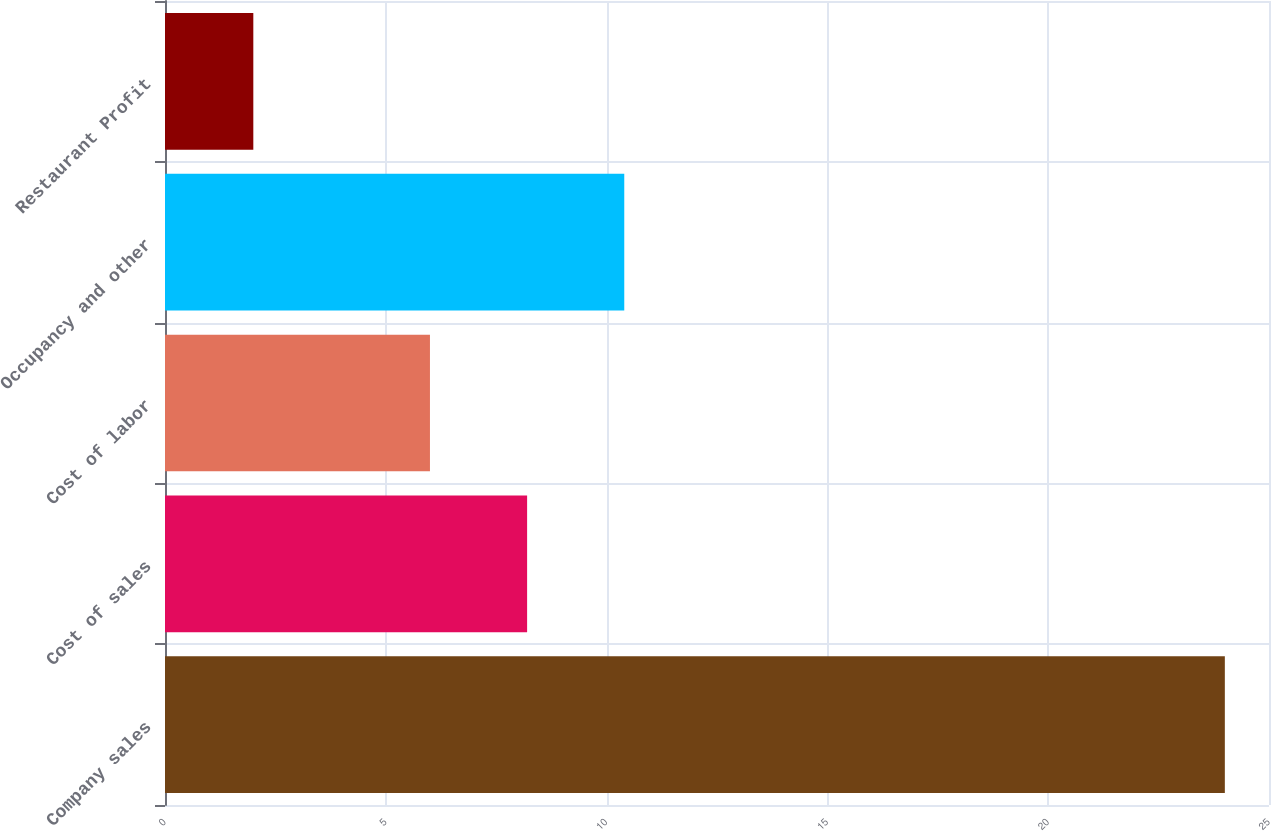Convert chart. <chart><loc_0><loc_0><loc_500><loc_500><bar_chart><fcel>Company sales<fcel>Cost of sales<fcel>Cost of labor<fcel>Occupancy and other<fcel>Restaurant Profit<nl><fcel>24<fcel>8.2<fcel>6<fcel>10.4<fcel>2<nl></chart> 